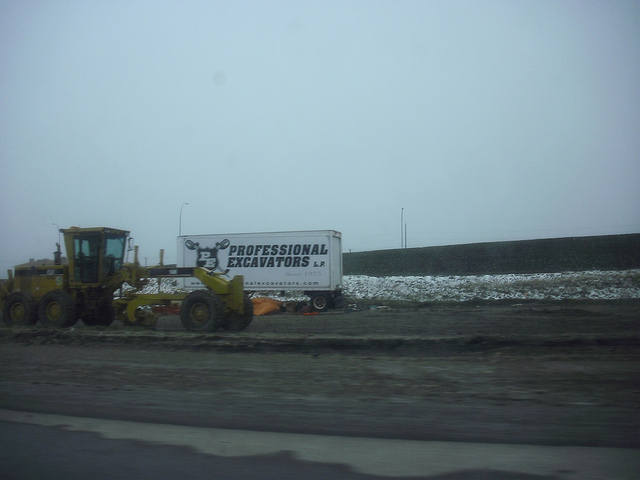<image>What did Mike build in the sand? It is not clear what Mike built in the sand. It could be a castle, a road, a tractor, a wall, or nothing at all. What did Mike build in the sand? I don't know what Mike built in the sand. It can be a castle, road, tractor, or wall. 